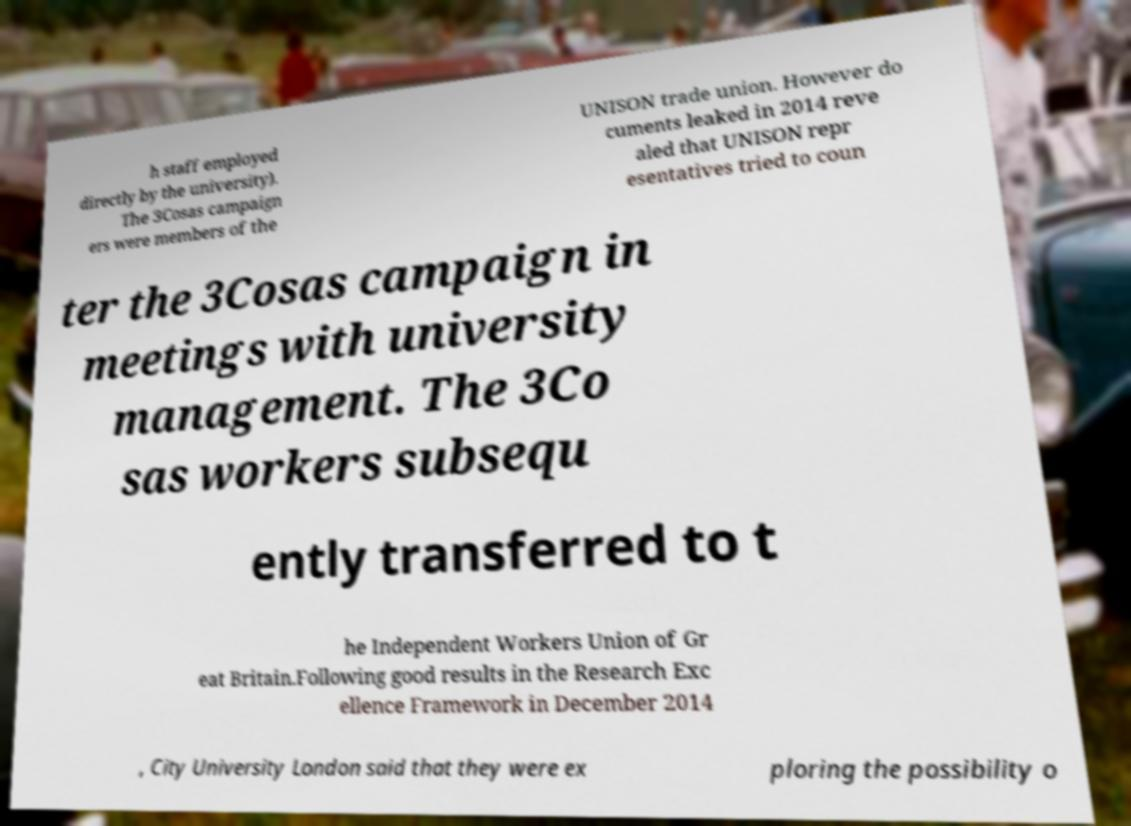Could you extract and type out the text from this image? h staff employed directly by the university). The 3Cosas campaign ers were members of the UNISON trade union. However do cuments leaked in 2014 reve aled that UNISON repr esentatives tried to coun ter the 3Cosas campaign in meetings with university management. The 3Co sas workers subsequ ently transferred to t he Independent Workers Union of Gr eat Britain.Following good results in the Research Exc ellence Framework in December 2014 , City University London said that they were ex ploring the possibility o 